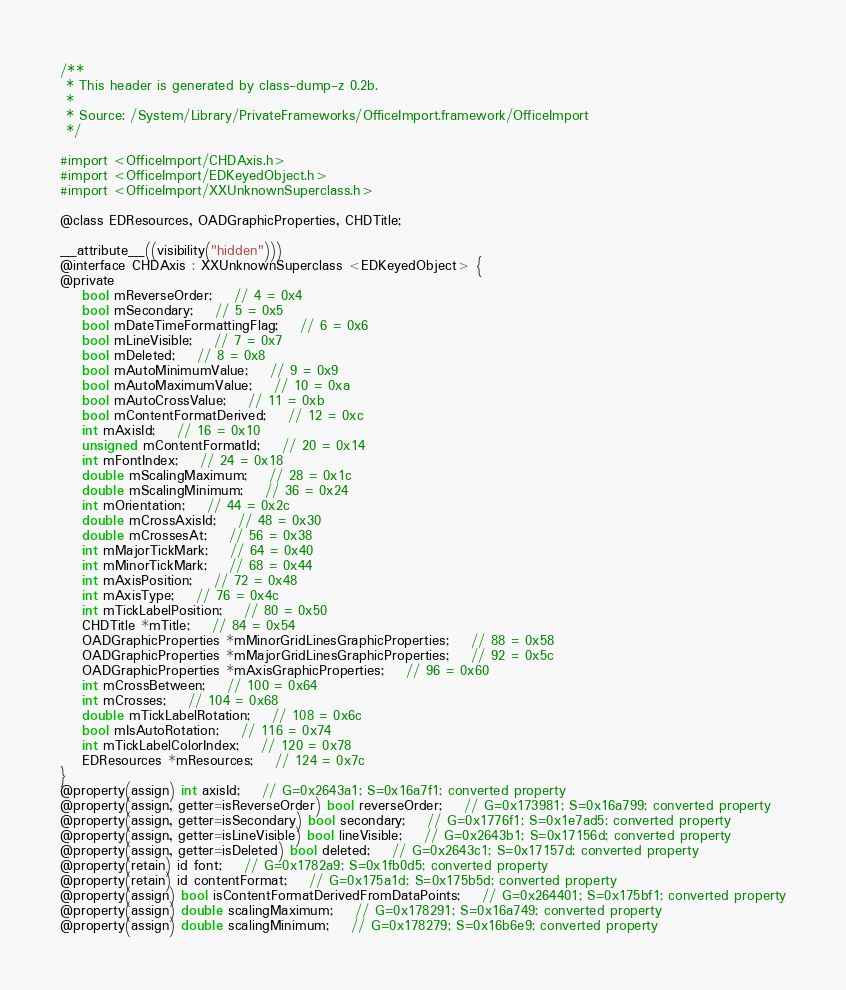<code> <loc_0><loc_0><loc_500><loc_500><_C_>/**
 * This header is generated by class-dump-z 0.2b.
 *
 * Source: /System/Library/PrivateFrameworks/OfficeImport.framework/OfficeImport
 */

#import <OfficeImport/CHDAxis.h>
#import <OfficeImport/EDKeyedObject.h>
#import <OfficeImport/XXUnknownSuperclass.h>

@class EDResources, OADGraphicProperties, CHDTitle;

__attribute__((visibility("hidden")))
@interface CHDAxis : XXUnknownSuperclass <EDKeyedObject> {
@private
	bool mReverseOrder;	// 4 = 0x4
	bool mSecondary;	// 5 = 0x5
	bool mDateTimeFormattingFlag;	// 6 = 0x6
	bool mLineVisible;	// 7 = 0x7
	bool mDeleted;	// 8 = 0x8
	bool mAutoMinimumValue;	// 9 = 0x9
	bool mAutoMaximumValue;	// 10 = 0xa
	bool mAutoCrossValue;	// 11 = 0xb
	bool mContentFormatDerived;	// 12 = 0xc
	int mAxisId;	// 16 = 0x10
	unsigned mContentFormatId;	// 20 = 0x14
	int mFontIndex;	// 24 = 0x18
	double mScalingMaximum;	// 28 = 0x1c
	double mScalingMinimum;	// 36 = 0x24
	int mOrientation;	// 44 = 0x2c
	double mCrossAxisId;	// 48 = 0x30
	double mCrossesAt;	// 56 = 0x38
	int mMajorTickMark;	// 64 = 0x40
	int mMinorTickMark;	// 68 = 0x44
	int mAxisPosition;	// 72 = 0x48
	int mAxisType;	// 76 = 0x4c
	int mTickLabelPosition;	// 80 = 0x50
	CHDTitle *mTitle;	// 84 = 0x54
	OADGraphicProperties *mMinorGridLinesGraphicProperties;	// 88 = 0x58
	OADGraphicProperties *mMajorGridLinesGraphicProperties;	// 92 = 0x5c
	OADGraphicProperties *mAxisGraphicProperties;	// 96 = 0x60
	int mCrossBetween;	// 100 = 0x64
	int mCrosses;	// 104 = 0x68
	double mTickLabelRotation;	// 108 = 0x6c
	bool mIsAutoRotation;	// 116 = 0x74
	int mTickLabelColorIndex;	// 120 = 0x78
	EDResources *mResources;	// 124 = 0x7c
}
@property(assign) int axisId;	// G=0x2643a1; S=0x16a7f1; converted property
@property(assign, getter=isReverseOrder) bool reverseOrder;	// G=0x173981; S=0x16a799; converted property
@property(assign, getter=isSecondary) bool secondary;	// G=0x1776f1; S=0x1e7ad5; converted property
@property(assign, getter=isLineVisible) bool lineVisible;	// G=0x2643b1; S=0x17156d; converted property
@property(assign, getter=isDeleted) bool deleted;	// G=0x2643c1; S=0x17157d; converted property
@property(retain) id font;	// G=0x1782a9; S=0x1fb0d5; converted property
@property(retain) id contentFormat;	// G=0x175a1d; S=0x175b5d; converted property
@property(assign) bool isContentFormatDerivedFromDataPoints;	// G=0x264401; S=0x175bf1; converted property
@property(assign) double scalingMaximum;	// G=0x178291; S=0x16a749; converted property
@property(assign) double scalingMinimum;	// G=0x178279; S=0x16b6e9; converted property</code> 